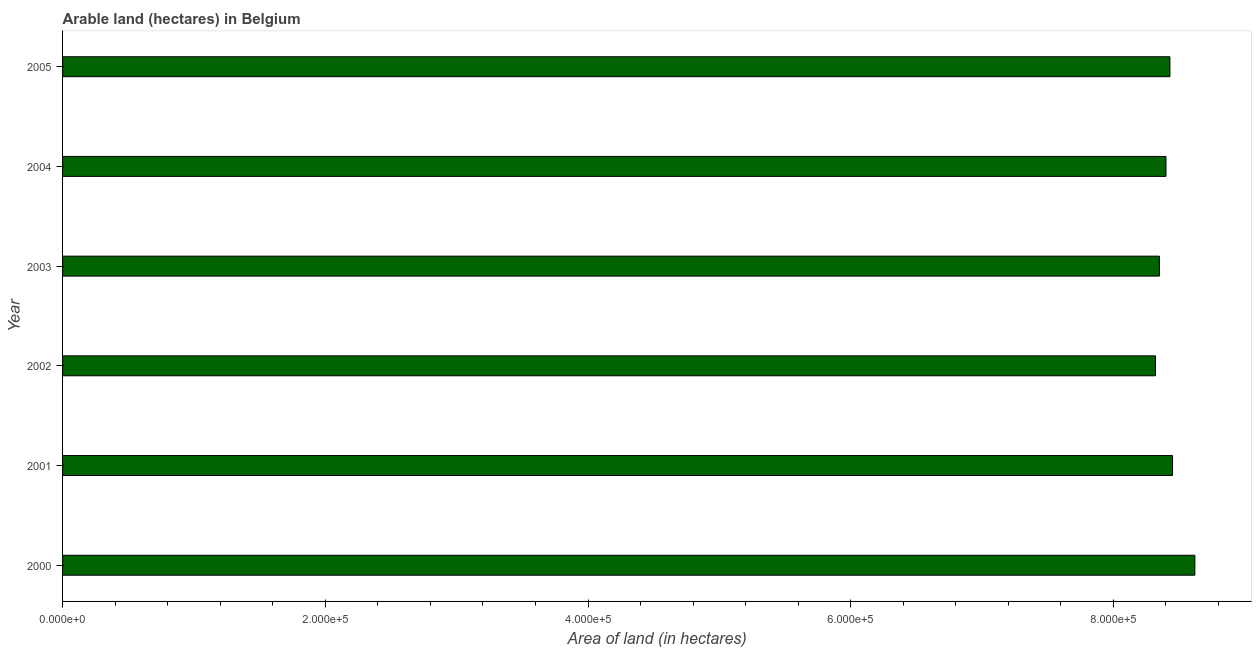Does the graph contain any zero values?
Provide a succinct answer. No. What is the title of the graph?
Offer a very short reply. Arable land (hectares) in Belgium. What is the label or title of the X-axis?
Offer a terse response. Area of land (in hectares). What is the area of land in 2003?
Your response must be concise. 8.35e+05. Across all years, what is the maximum area of land?
Ensure brevity in your answer.  8.62e+05. Across all years, what is the minimum area of land?
Offer a very short reply. 8.32e+05. In which year was the area of land maximum?
Your answer should be compact. 2000. What is the sum of the area of land?
Give a very brief answer. 5.06e+06. What is the difference between the area of land in 2001 and 2002?
Give a very brief answer. 1.30e+04. What is the average area of land per year?
Ensure brevity in your answer.  8.43e+05. What is the median area of land?
Your response must be concise. 8.42e+05. Do a majority of the years between 2002 and 2004 (inclusive) have area of land greater than 440000 hectares?
Your answer should be very brief. Yes. Is the area of land in 2004 less than that in 2005?
Make the answer very short. Yes. What is the difference between the highest and the second highest area of land?
Provide a succinct answer. 1.70e+04. Is the sum of the area of land in 2000 and 2004 greater than the maximum area of land across all years?
Keep it short and to the point. Yes. What is the difference between the highest and the lowest area of land?
Your answer should be very brief. 3.00e+04. How many years are there in the graph?
Give a very brief answer. 6. What is the difference between two consecutive major ticks on the X-axis?
Your answer should be very brief. 2.00e+05. Are the values on the major ticks of X-axis written in scientific E-notation?
Offer a terse response. Yes. What is the Area of land (in hectares) of 2000?
Keep it short and to the point. 8.62e+05. What is the Area of land (in hectares) of 2001?
Make the answer very short. 8.45e+05. What is the Area of land (in hectares) of 2002?
Make the answer very short. 8.32e+05. What is the Area of land (in hectares) of 2003?
Offer a very short reply. 8.35e+05. What is the Area of land (in hectares) of 2004?
Ensure brevity in your answer.  8.40e+05. What is the Area of land (in hectares) in 2005?
Offer a terse response. 8.43e+05. What is the difference between the Area of land (in hectares) in 2000 and 2001?
Your answer should be compact. 1.70e+04. What is the difference between the Area of land (in hectares) in 2000 and 2003?
Your answer should be very brief. 2.70e+04. What is the difference between the Area of land (in hectares) in 2000 and 2004?
Your answer should be very brief. 2.20e+04. What is the difference between the Area of land (in hectares) in 2000 and 2005?
Your answer should be very brief. 1.90e+04. What is the difference between the Area of land (in hectares) in 2001 and 2002?
Ensure brevity in your answer.  1.30e+04. What is the difference between the Area of land (in hectares) in 2001 and 2004?
Your response must be concise. 5000. What is the difference between the Area of land (in hectares) in 2001 and 2005?
Keep it short and to the point. 2000. What is the difference between the Area of land (in hectares) in 2002 and 2003?
Keep it short and to the point. -3000. What is the difference between the Area of land (in hectares) in 2002 and 2004?
Offer a terse response. -8000. What is the difference between the Area of land (in hectares) in 2002 and 2005?
Your response must be concise. -1.10e+04. What is the difference between the Area of land (in hectares) in 2003 and 2004?
Your answer should be very brief. -5000. What is the difference between the Area of land (in hectares) in 2003 and 2005?
Provide a short and direct response. -8000. What is the difference between the Area of land (in hectares) in 2004 and 2005?
Keep it short and to the point. -3000. What is the ratio of the Area of land (in hectares) in 2000 to that in 2002?
Your answer should be very brief. 1.04. What is the ratio of the Area of land (in hectares) in 2000 to that in 2003?
Offer a terse response. 1.03. What is the ratio of the Area of land (in hectares) in 2000 to that in 2004?
Offer a terse response. 1.03. What is the ratio of the Area of land (in hectares) in 2000 to that in 2005?
Your response must be concise. 1.02. What is the ratio of the Area of land (in hectares) in 2001 to that in 2002?
Make the answer very short. 1.02. What is the ratio of the Area of land (in hectares) in 2001 to that in 2003?
Make the answer very short. 1.01. What is the ratio of the Area of land (in hectares) in 2001 to that in 2004?
Your answer should be compact. 1.01. What is the ratio of the Area of land (in hectares) in 2002 to that in 2005?
Provide a short and direct response. 0.99. What is the ratio of the Area of land (in hectares) in 2003 to that in 2004?
Your answer should be very brief. 0.99. What is the ratio of the Area of land (in hectares) in 2004 to that in 2005?
Make the answer very short. 1. 